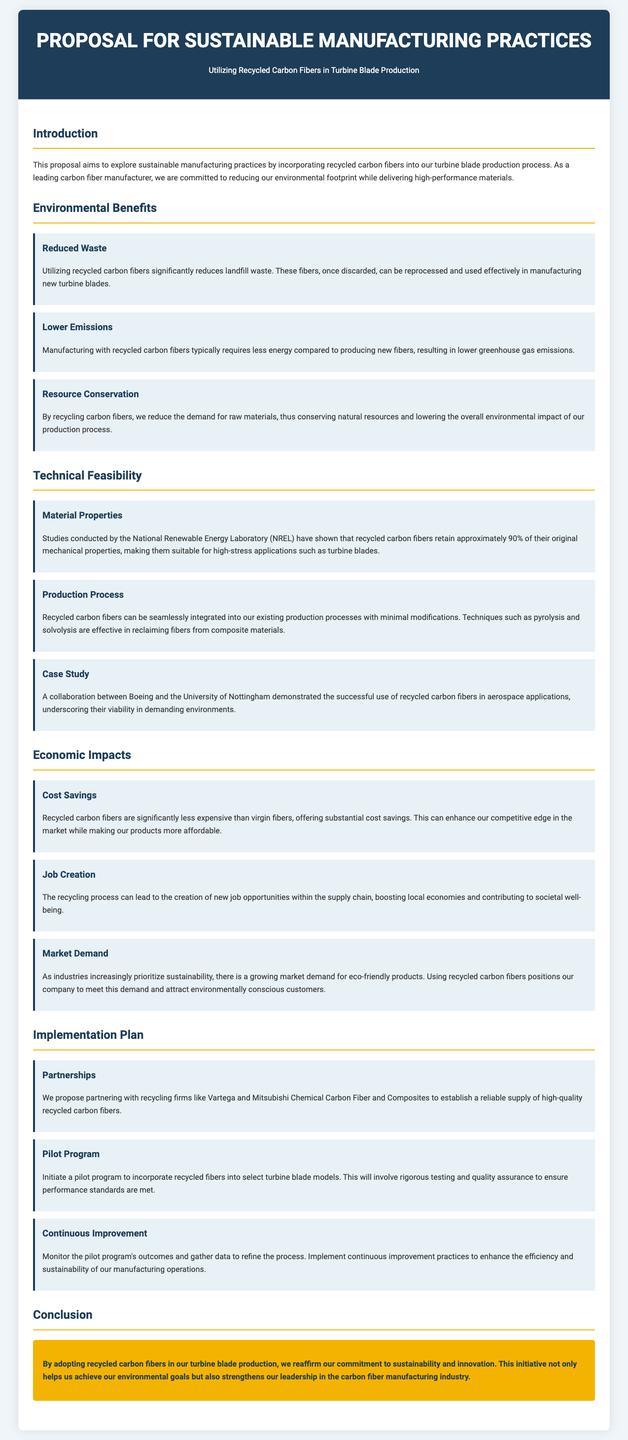What is the title of the proposal? The title of the proposal is the main heading presented in the document, which introduces the topic.
Answer: Proposal for Sustainable Manufacturing Practices What are the environmental benefits of using recycled carbon fibers? The document lists specific environmental benefits including reduced waste, lower emissions, and resource conservation.
Answer: Reduced waste, lower emissions, resource conservation What is the percentage of original mechanical properties retained by recycled carbon fibers? The document mentions a specific percentage that indicates the suitability of the recycled fibers for high-stress applications.
Answer: 90% Who did a case study on recycled carbon fibers in aerospace applications? The document references a collaboration that provides evidence for the viability of recycled carbon fibers in demanding environments.
Answer: Boeing and the University of Nottingham What are the proposed partnerships for ensuring a supply of recycled carbon fibers? The document lists specific companies as potential partners for establishing a reliable source of recycled fibers.
Answer: Vartega and Mitsubishi Chemical Carbon Fiber and Composites What is one of the aspects of the implementation plan? The document outlines major steps that would be taken as part of the implementation plan to incorporate recycled fibers in production.
Answer: Pilot program What are the expected economic impacts mentioned in the proposal? The document identifies distinct economic outcomes that would arise from utilizing recycled carbon fibers, including cost savings and job creation.
Answer: Cost savings, job creation, market demand What is the color of the conclusion section in the proposal? The document describes the styling of the conclusion section to convey its significance visually.
Answer: Yellow What is the primary commitment expressed in the conclusion? The conclusion emphasizes a specific goal that the company aims to achieve through the proposed initiative.
Answer: Commitment to sustainability and innovation 